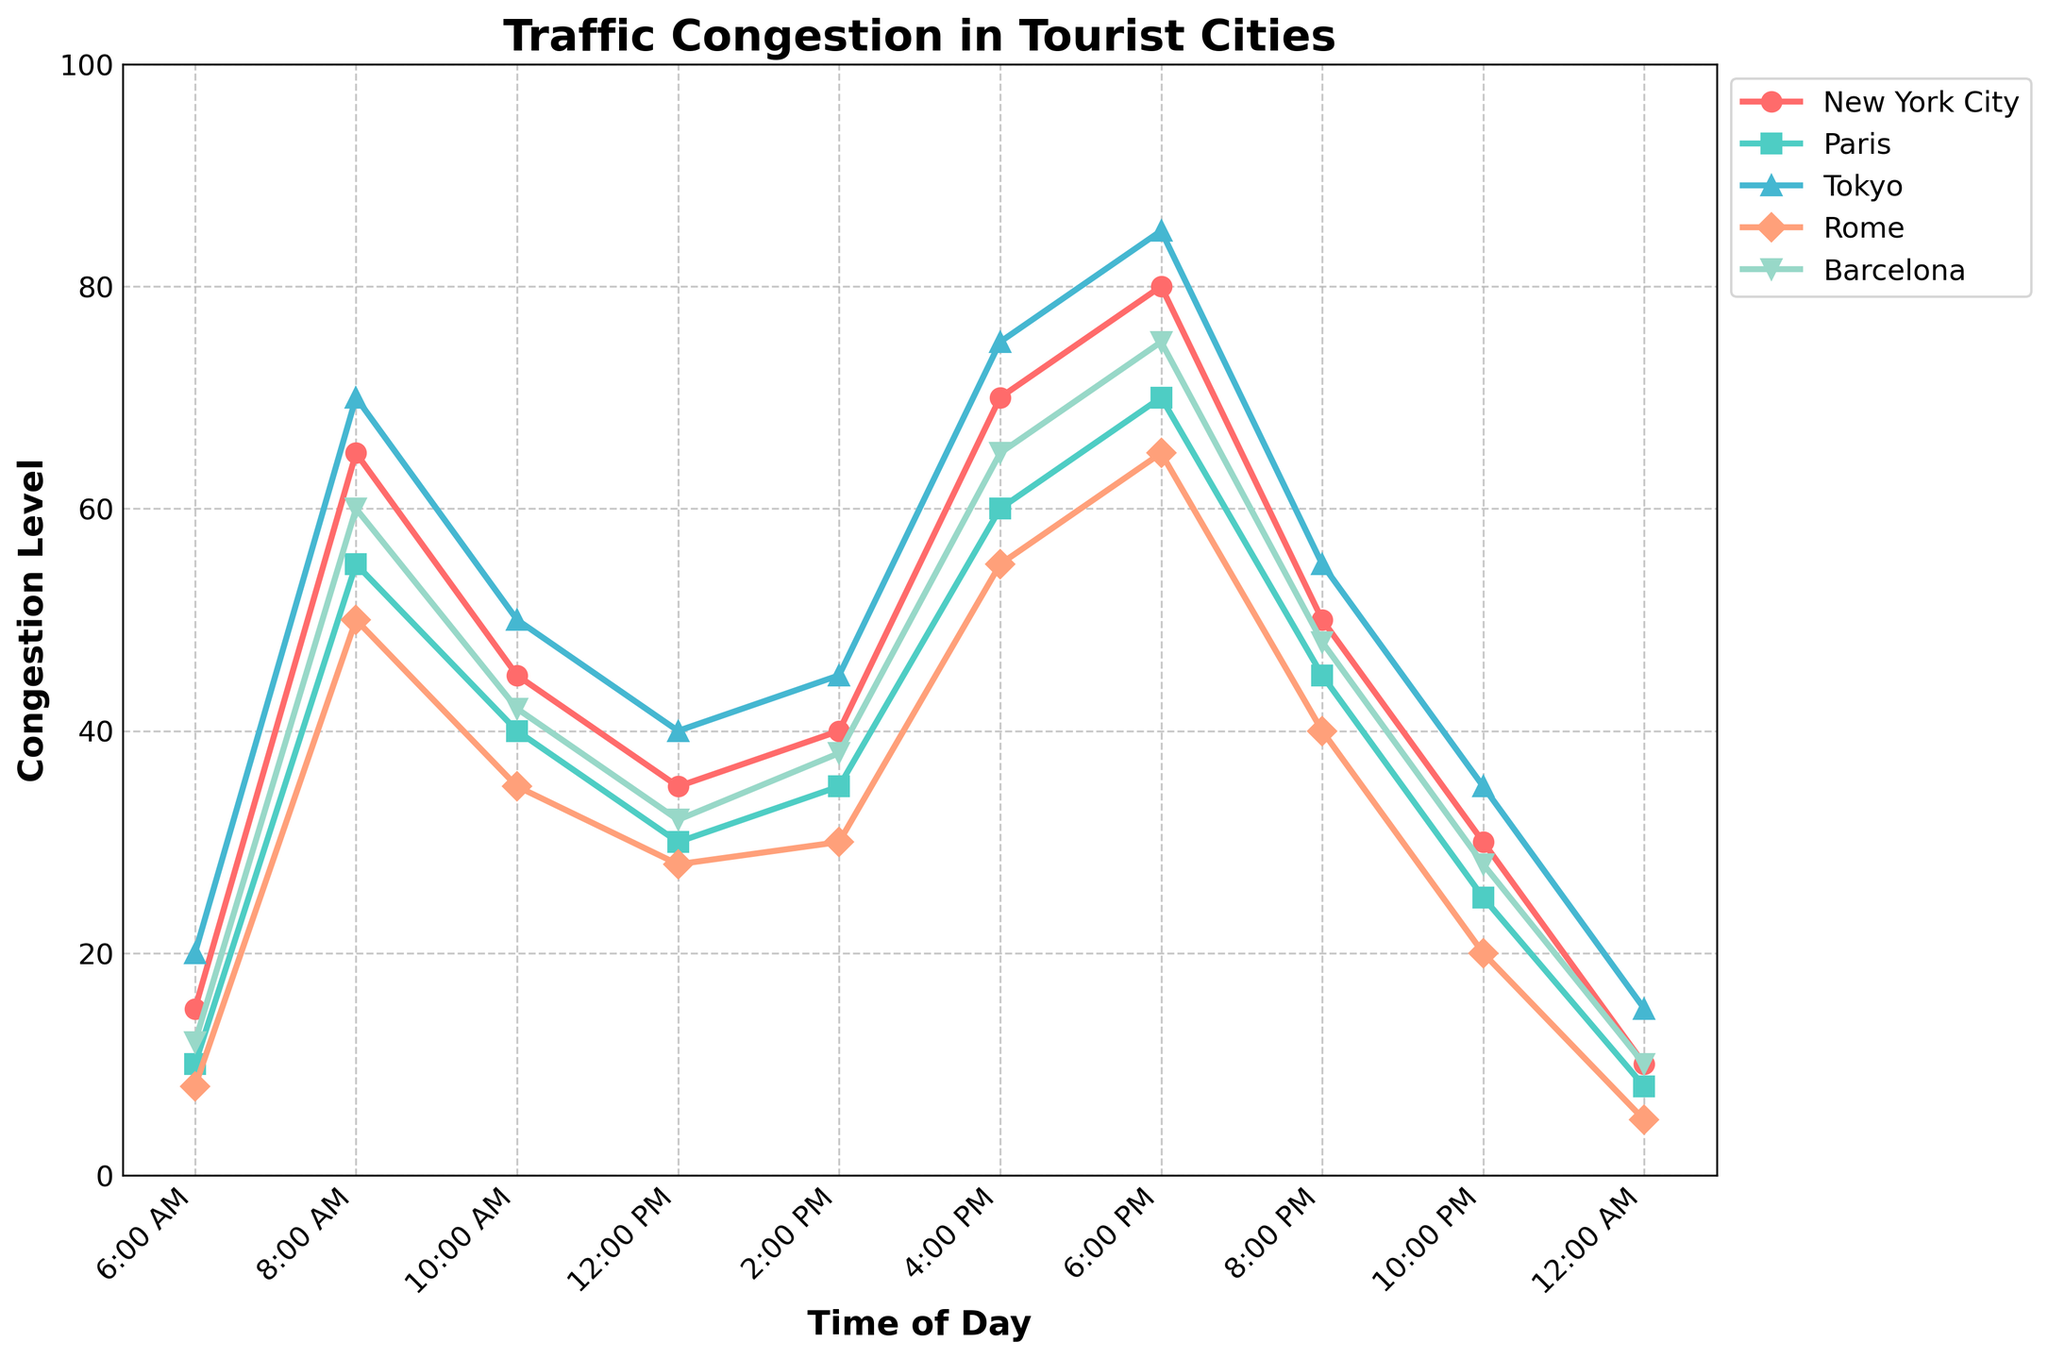What time of day does New York City experience the highest congestion level? Look for the peak point on the New York City line. This is at 6:00 PM where the congestion level reaches 80.
Answer: 6:00 PM Which city has the lowest congestion level at 12:00 AM? Compare the congestion levels of all cities at 12:00 AM. Rome has the lowest with a level of 5.
Answer: Rome How does Paris’ congestion level at 8:00 PM compare with its level at 6:00 PM? Paris' congestion level at 8:00 PM is 45 and at 6:00 PM it is 70. Therefore, the level at 8:00 PM is lower.
Answer: Lower Which city has the steepest increase in congestion between 6:00 AM and 8:00 AM? Look at the change in congestion levels between 6:00 AM and 8:00 AM for each city, and find the largest increase. Tokyo sees the steepest increase from 20 to 70, a 50-point rise.
Answer: Tokyo What is the average congestion level in Rome from 10:00 AM to 6:00 PM? Sum Rome’s congestion levels at 10:00 AM, 12:00 PM, 2:00 PM, 4:00 PM, and 6:00 PM, then divide by 5. The sum is 35 + 28 + 30 + 55 + 65 = 213. The average is 213/5 = 42.6.
Answer: 42.6 During which time periods does New York City have a higher congestion level than Barcelona? Compare the congestion levels of New York City and Barcelona for all time periods. New York City has higher levels at 8:00 AM, 4:00 PM, 6:00 PM.
Answer: 8:00 AM, 4:00 PM, 6:00 PM What is the difference between the highest and lowest congestion levels in Tokyo? Determine Tokyo’s highest congestion level (85 at 6:00 PM) and lowest (15 at 12:00 AM). The difference is 85 - 15 = 70.
Answer: 70 Which city has the most consistent congestion level throughout the day? Look for the city whose congestion levels have the least variation throughout the day. Barcelona shows the most consistency, staying fairly close throughout the day.
Answer: Barcelona From 2:00 PM to 6:00 PM, how much does the congestion level increase in Paris? Substract the congestion level in Paris at 2:00 PM from that at 6:00 PM. The change is 70 - 35 = 35.
Answer: 35 At what time does congestion level in Rome surpass the level in Barcelona for the first time of the day? Compare Rome and Barcelona congestion levels starting from 6:00 AM until Rome’s level first exceeds Barcelona’s. This occurs at 12:00 PM.
Answer: 12:00 PM 